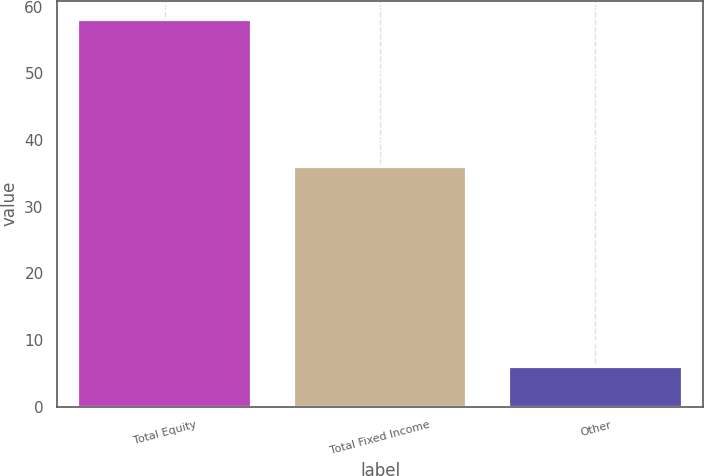Convert chart. <chart><loc_0><loc_0><loc_500><loc_500><bar_chart><fcel>Total Equity<fcel>Total Fixed Income<fcel>Other<nl><fcel>58<fcel>36<fcel>6<nl></chart> 